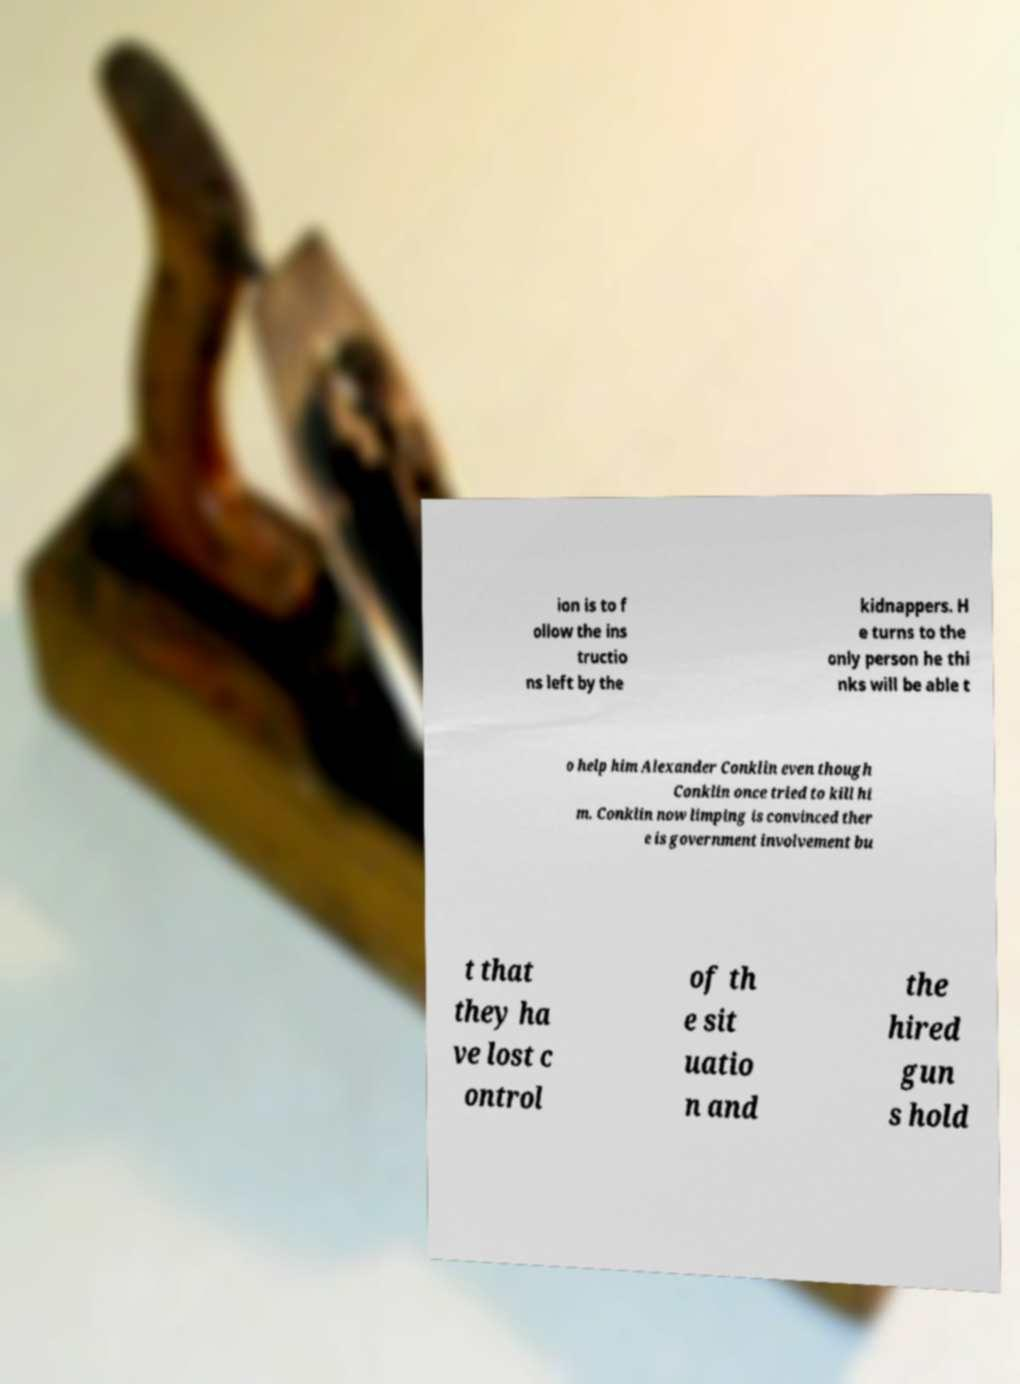Please identify and transcribe the text found in this image. ion is to f ollow the ins tructio ns left by the kidnappers. H e turns to the only person he thi nks will be able t o help him Alexander Conklin even though Conklin once tried to kill hi m. Conklin now limping is convinced ther e is government involvement bu t that they ha ve lost c ontrol of th e sit uatio n and the hired gun s hold 